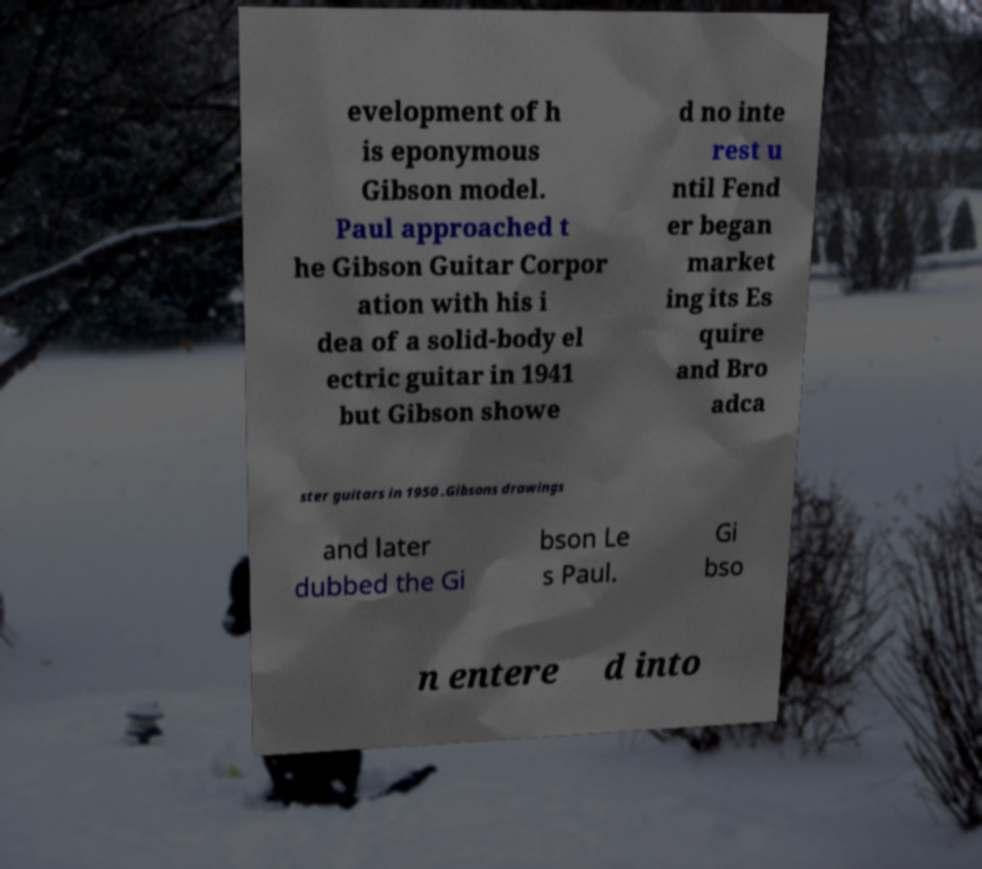There's text embedded in this image that I need extracted. Can you transcribe it verbatim? evelopment of h is eponymous Gibson model. Paul approached t he Gibson Guitar Corpor ation with his i dea of a solid-body el ectric guitar in 1941 but Gibson showe d no inte rest u ntil Fend er began market ing its Es quire and Bro adca ster guitars in 1950 .Gibsons drawings and later dubbed the Gi bson Le s Paul. Gi bso n entere d into 